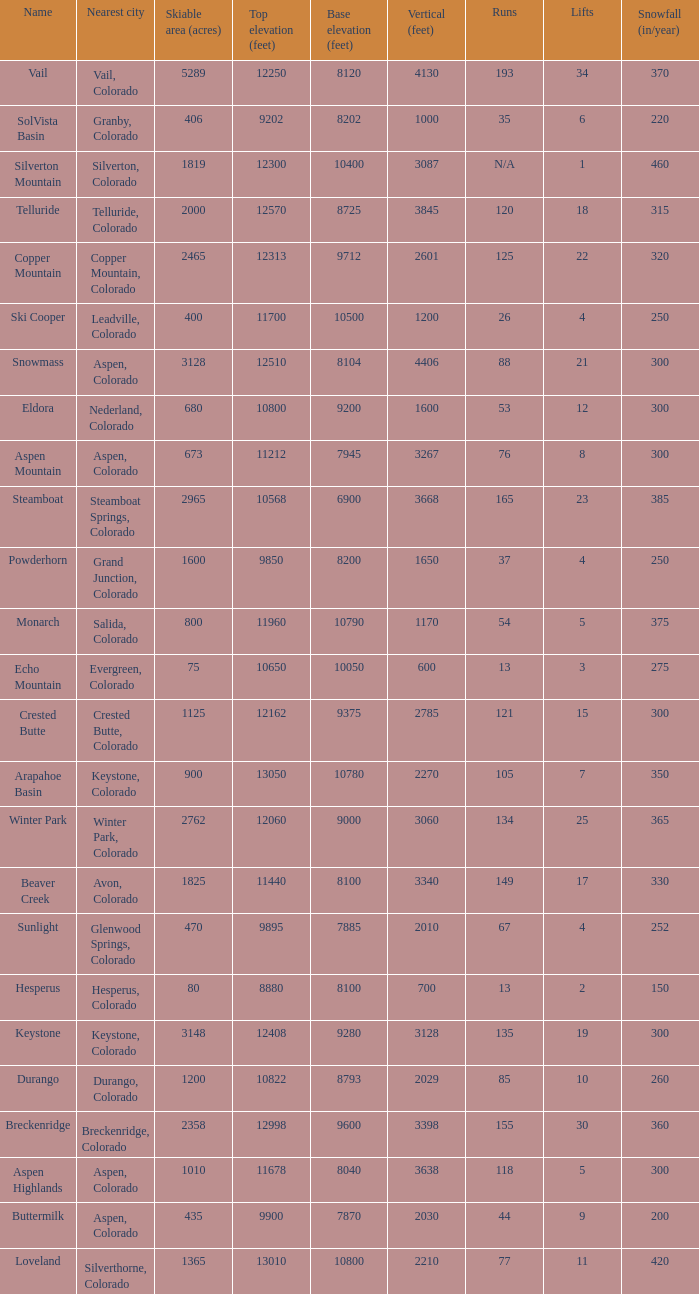If there are 11 lifts, what is the base elevation? 10800.0. 